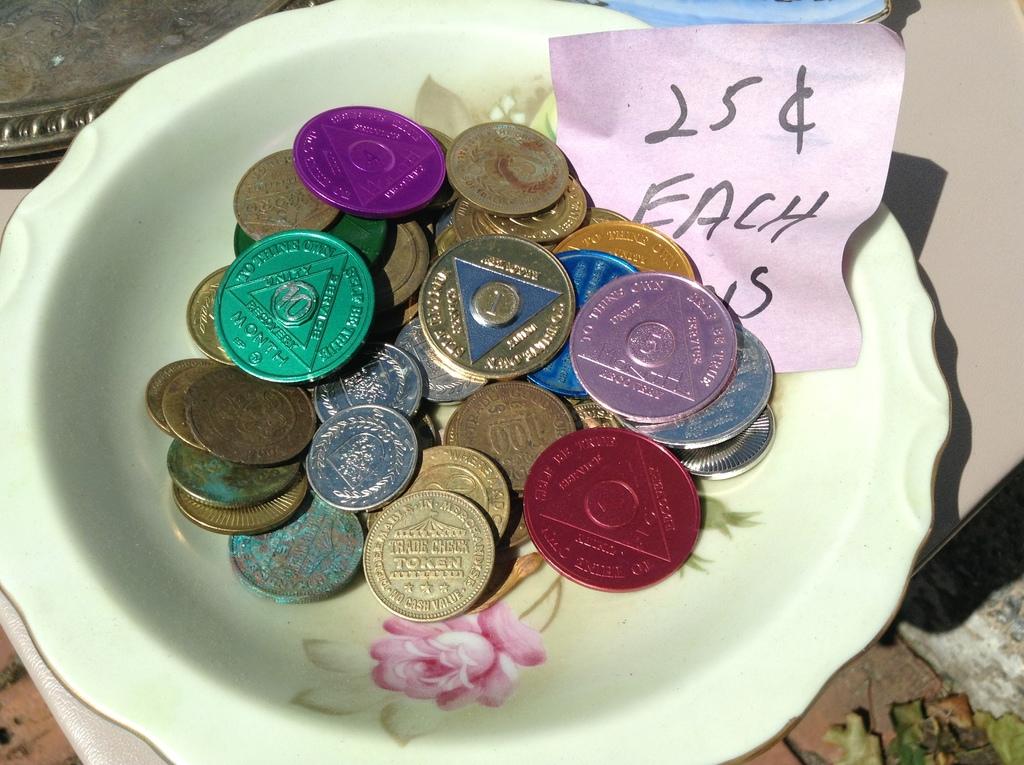How many cents does each coin cost?
Give a very brief answer. 25. 